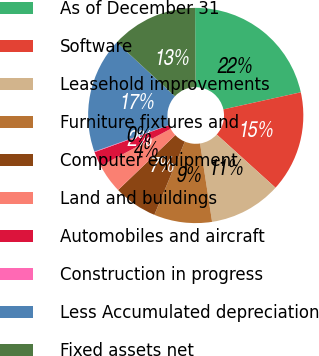Convert chart. <chart><loc_0><loc_0><loc_500><loc_500><pie_chart><fcel>As of December 31<fcel>Software<fcel>Leasehold improvements<fcel>Furniture fixtures and<fcel>Computer equipment<fcel>Land and buildings<fcel>Automobiles and aircraft<fcel>Construction in progress<fcel>Less Accumulated depreciation<fcel>Fixed assets net<nl><fcel>21.64%<fcel>15.17%<fcel>10.86%<fcel>8.71%<fcel>6.55%<fcel>4.4%<fcel>2.24%<fcel>0.09%<fcel>17.33%<fcel>13.02%<nl></chart> 